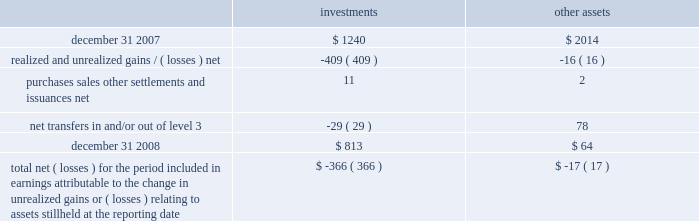A wholly-owned subsidiary of the company is a registered life insurance company that maintains separate account assets , representing segregated funds held for purposes of funding individual and group pension contracts , and equal and offsetting separate account liabilities .
At decem - ber 31 , 2008 and 2007 , the level 3 separate account assets were approximately $ 4 and $ 12 , respectively .
The changes in level 3 assets primarily relate to purchases , sales and gains/ ( losses ) .
The net investment income and net gains and losses attributable to separate account assets accrue directly to the contract owner and are not reported as non-operating income ( expense ) on the consolidated statements of income .
Level 3 assets , which includes equity method investments or consolidated investments of real estate funds , private equity funds and funds of private equity funds are valued based upon valuations received from internal as well as third party fund managers .
Fair valuations at the underlying funds are based on a combination of methods which may include third-party independent appraisals and discounted cash flow techniques .
Direct investments in private equity companies held by funds of private equity funds are valued based on an assessment of each under - lying investment , incorporating evaluation of additional significant third party financing , changes in valuations of comparable peer companies and the business environment of the companies , among other factors .
See note 2 for further detail on the fair value policies by the underlying funds .
Changes in level 3 assets measured at fair value on a recurring basis for the year ended december 31 , 2008 .
Total net ( losses ) for the period included in earnings attributable to the change in unrealized gains or ( losses ) relating to assets still held at the reporting date $ ( 366 ) $ ( 17 ) realized and unrealized gains and losses recorded for level 3 assets are reported in non-operating income ( expense ) on the consolidated statements of income .
Non-controlling interest expense is recorded for consoli- dated investments to reflect the portion of gains and losses not attributable to the company .
The company transfers assets in and/or out of level 3 as significant inputs , including performance attributes , used for the fair value measurement become observable .
Variable interest entities in the normal course of business , the company is the manager of various types of sponsored investment vehicles , including collateralized debt obligations and sponsored investment funds , that may be considered vies .
The company receives management fees or other incen- tive related fees for its services and may from time to time own equity or debt securities or enter into derivatives with the vehicles , each of which are considered variable inter- ests .
The company engages in these variable interests principally to address client needs through the launch of such investment vehicles .
The vies are primarily financed via capital contributed by equity and debt holders .
The company 2019s involvement in financing the operations of the vies is limited to its equity interests , unfunded capital commitments for certain sponsored investment funds and its capital support agreements for two enhanced cash funds .
The primary beneficiary of a vie is the party that absorbs a majority of the entity 2019s expected losses , receives a major - ity of the entity 2019s expected residual returns or both as a result of holding variable interests .
In order to determine whether the company is the primary beneficiary of a vie , management must make significant estimates and assumptions of probable future cash flows and assign probabilities to different cash flow scenarios .
Assumptions made in such analyses include , but are not limited to , market prices of securities , market interest rates , poten- tial credit defaults on individual securities or default rates on a portfolio of securities , gain realization , liquidity or marketability of certain securities , discount rates and the probability of certain other outcomes .
Vies in which blackrock is the primary beneficiary at december 31 , 2008 , the company was the primary beneficiary of three vies , which resulted in consolidation of three sponsored investment funds ( including two cash management funds and one private equity fund of funds ) .
Creditors of the vies do not have recourse to the credit of the company .
During 2008 , the company determined it became the primary beneficiary of two enhanced cash management funds as a result of concluding that under various cash 177528_txt_59_96:layout 1 3/26/09 10:32 pm page 73 .
What is the percentage change in the balance of level 3 investments assets from 2007 to 2008? 
Computations: ((813 - 1240) / 1240)
Answer: -0.34435. 